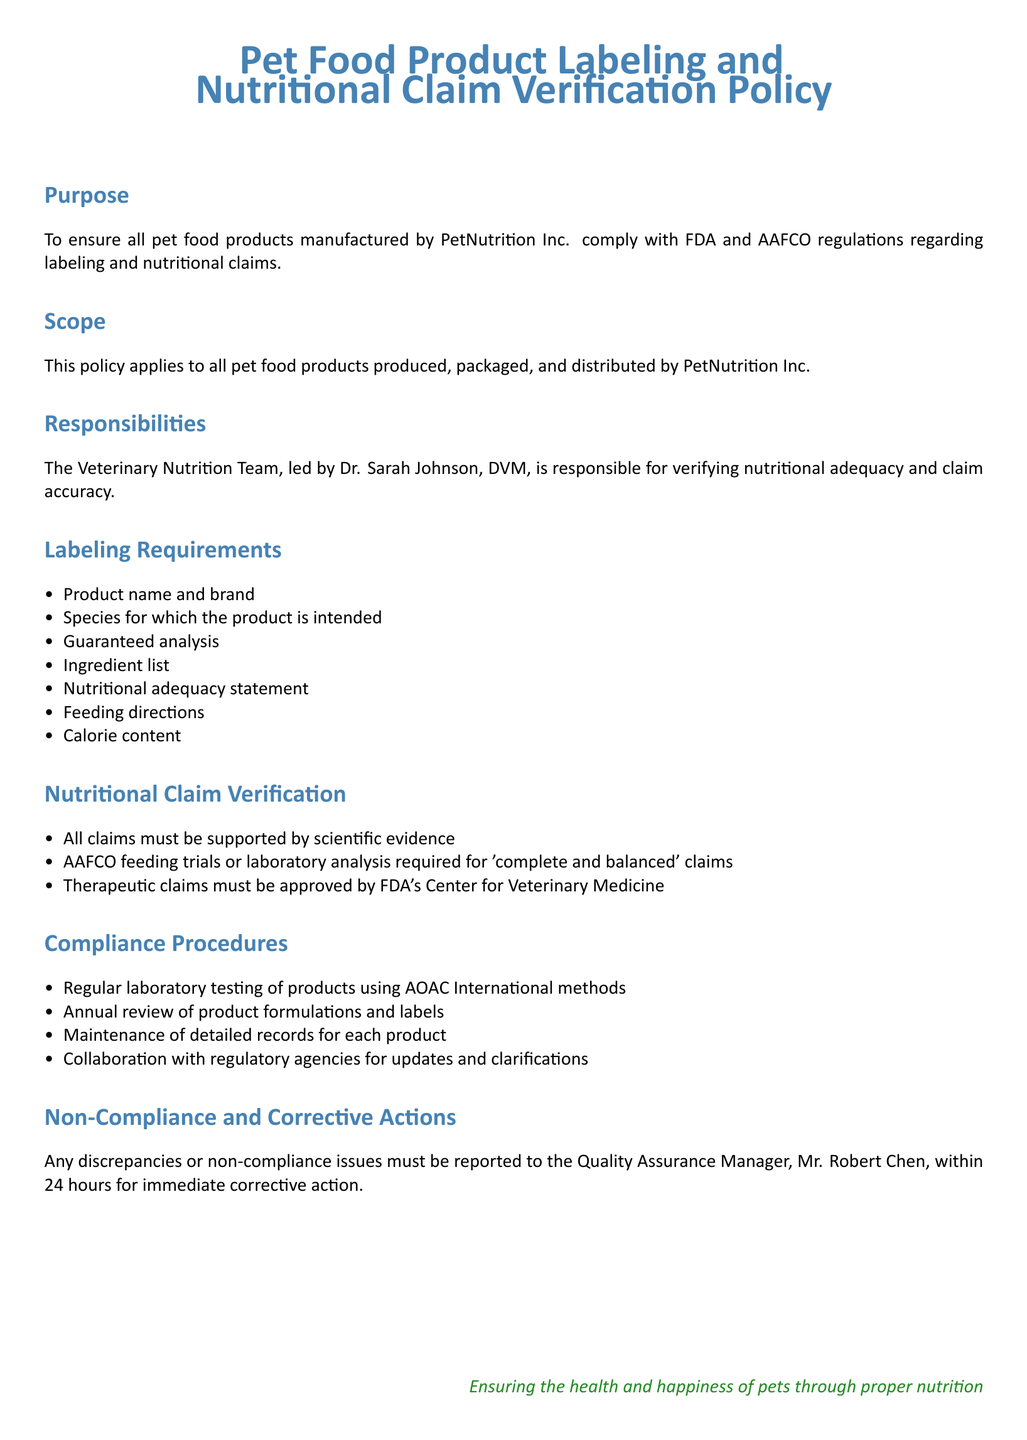What is the purpose of the policy? The purpose of the policy is to ensure compliance with FDA and AAFCO regulations regarding labeling and nutritional claims for pet food products.
Answer: To ensure compliance with FDA and AAFCO regulations Who is responsible for verifying nutritional adequacy? The Veterinary Nutrition Team is responsible for verifying nutritional adequacy and claim accuracy, led by Dr. Sarah Johnson.
Answer: Dr. Sarah Johnson What must claims be supported by? The document states that all claims must be supported by scientific evidence.
Answer: Scientific evidence What is required for 'complete and balanced' claims? AAFCO feeding trials or laboratory analysis are required for 'complete and balanced' claims.
Answer: AAFCO feeding trials or laboratory analysis Who should report non-compliance issues? The Quality Assurance Manager, Mr. Robert Chen, should be contacted for non-compliance issues.
Answer: Mr. Robert Chen How often should product formulations and labels be reviewed? The policy mandates an annual review of product formulations and labels.
Answer: Annual What color is used for the document title? The document title uses a specific color identified as pet blue.
Answer: Pet blue What does the policy state about therapeutic claims? Therapeutic claims must be approved by FDA's Center for Veterinary Medicine.
Answer: FDA's Center for Veterinary Medicine What kind of methods are used for laboratory testing? The document specifies using AOAC International methods for laboratory testing.
Answer: AOAC International methods 